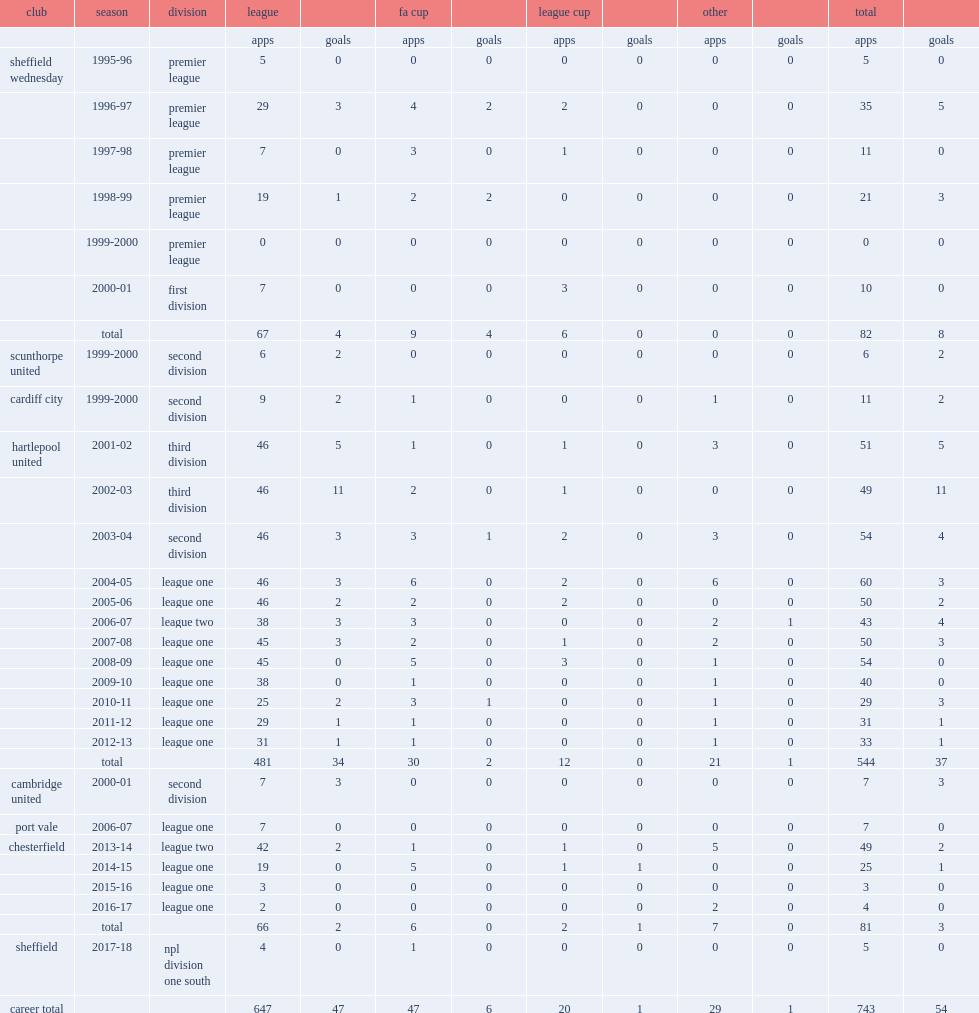With hartlepool, how appearances did ritchie humphreys make? 544.0. 